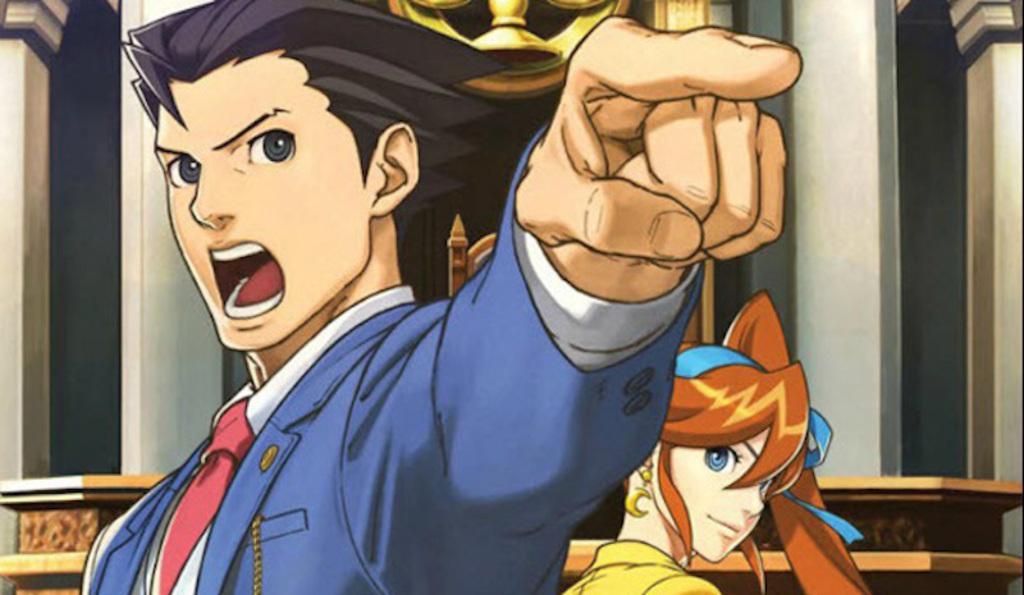Please provide a concise description of this image. This image is an animation. In the center of the image we can see a man and a lady. In the background there is a wall. 